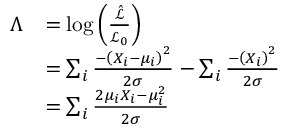<formula> <loc_0><loc_0><loc_500><loc_500>\begin{array} { r l } { \Lambda } & { = \log \left ( \frac { \hat { \mathcal { L } } } { \mathcal { L _ { 0 } } } \right ) } \\ & { = \sum _ { i } \frac { - \left ( X _ { i } - \mu _ { i } \right ) ^ { 2 } } { 2 \sigma } - \sum _ { i } \frac { - \left ( X _ { i } \right ) ^ { 2 } } { 2 \sigma } } \\ & { = \sum _ { i } \frac { 2 \mu _ { i } X _ { i } - \mu _ { i } ^ { 2 } } { 2 \sigma } } \end{array}</formula> 